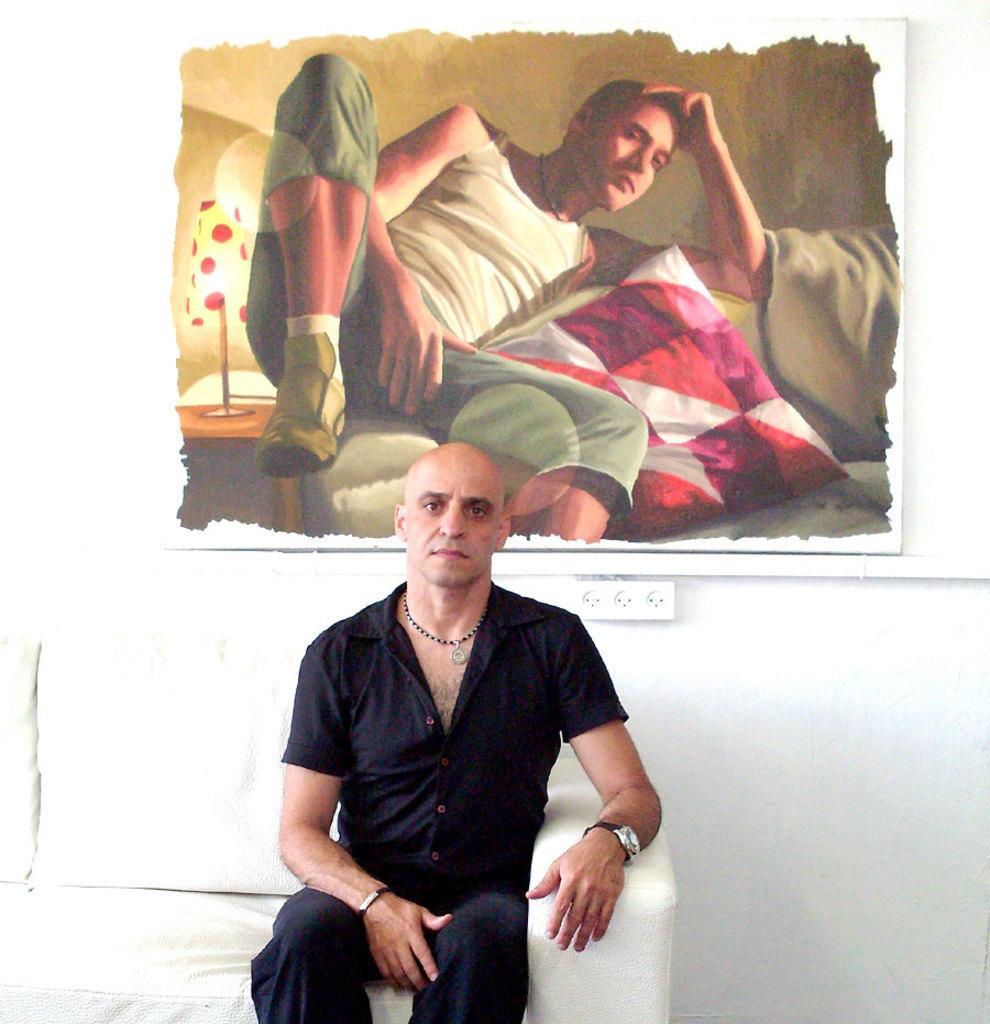Can you describe this image briefly? In this image there is a person sitting on the sofa, behind him there is a poster of a person lay on the sofa, beside him there is a pillow and on the other side there is a lamp on the table, which is attached to the wall, below the poster there is a switchboard. 